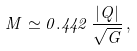Convert formula to latex. <formula><loc_0><loc_0><loc_500><loc_500>M \simeq 0 . 4 4 2 \, \frac { | Q | } { \sqrt { G } } \, ,</formula> 